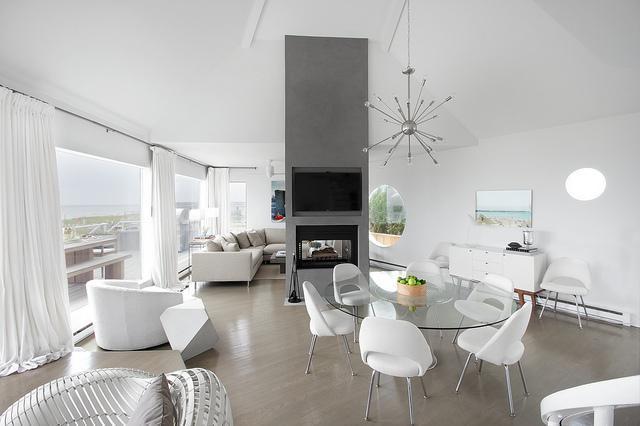How many chairs are in the photo?
Give a very brief answer. 5. How many tvs are in the photo?
Give a very brief answer. 2. 